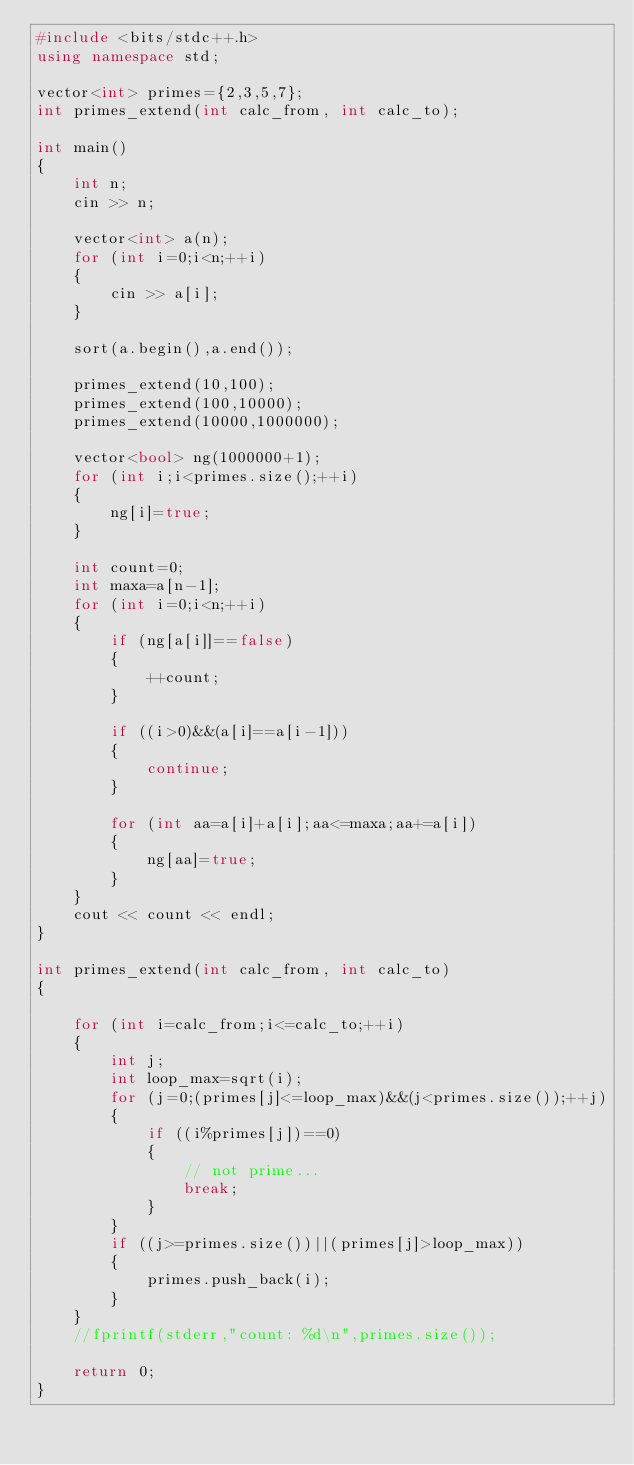Convert code to text. <code><loc_0><loc_0><loc_500><loc_500><_C++_>#include <bits/stdc++.h>
using namespace std;

vector<int> primes={2,3,5,7};
int primes_extend(int calc_from, int calc_to);

int main()
{
	int n;
	cin >> n;

	vector<int> a(n);
	for (int i=0;i<n;++i)
	{
		cin >> a[i];
	}

	sort(a.begin(),a.end());

	primes_extend(10,100);
	primes_extend(100,10000);
	primes_extend(10000,1000000);

	vector<bool> ng(1000000+1);
	for (int i;i<primes.size();++i)
	{
		ng[i]=true;
	}

	int count=0;
	int maxa=a[n-1];
	for (int i=0;i<n;++i)
	{
		if (ng[a[i]]==false)
		{
			++count;
		}

		if ((i>0)&&(a[i]==a[i-1]))
		{
			continue;
		}

		for (int aa=a[i]+a[i];aa<=maxa;aa+=a[i])
		{
			ng[aa]=true;
		}
	}
	cout << count << endl;
}

int primes_extend(int calc_from, int calc_to)
{

	for (int i=calc_from;i<=calc_to;++i)
	{
		int j;
		int loop_max=sqrt(i);
		for (j=0;(primes[j]<=loop_max)&&(j<primes.size());++j)
		{
			if ((i%primes[j])==0)
			{
				// not prime...
				break;
			}
		}
		if ((j>=primes.size())||(primes[j]>loop_max))
		{
			primes.push_back(i);
		}
	}
	//fprintf(stderr,"count: %d\n",primes.size());

	return 0;
}





</code> 